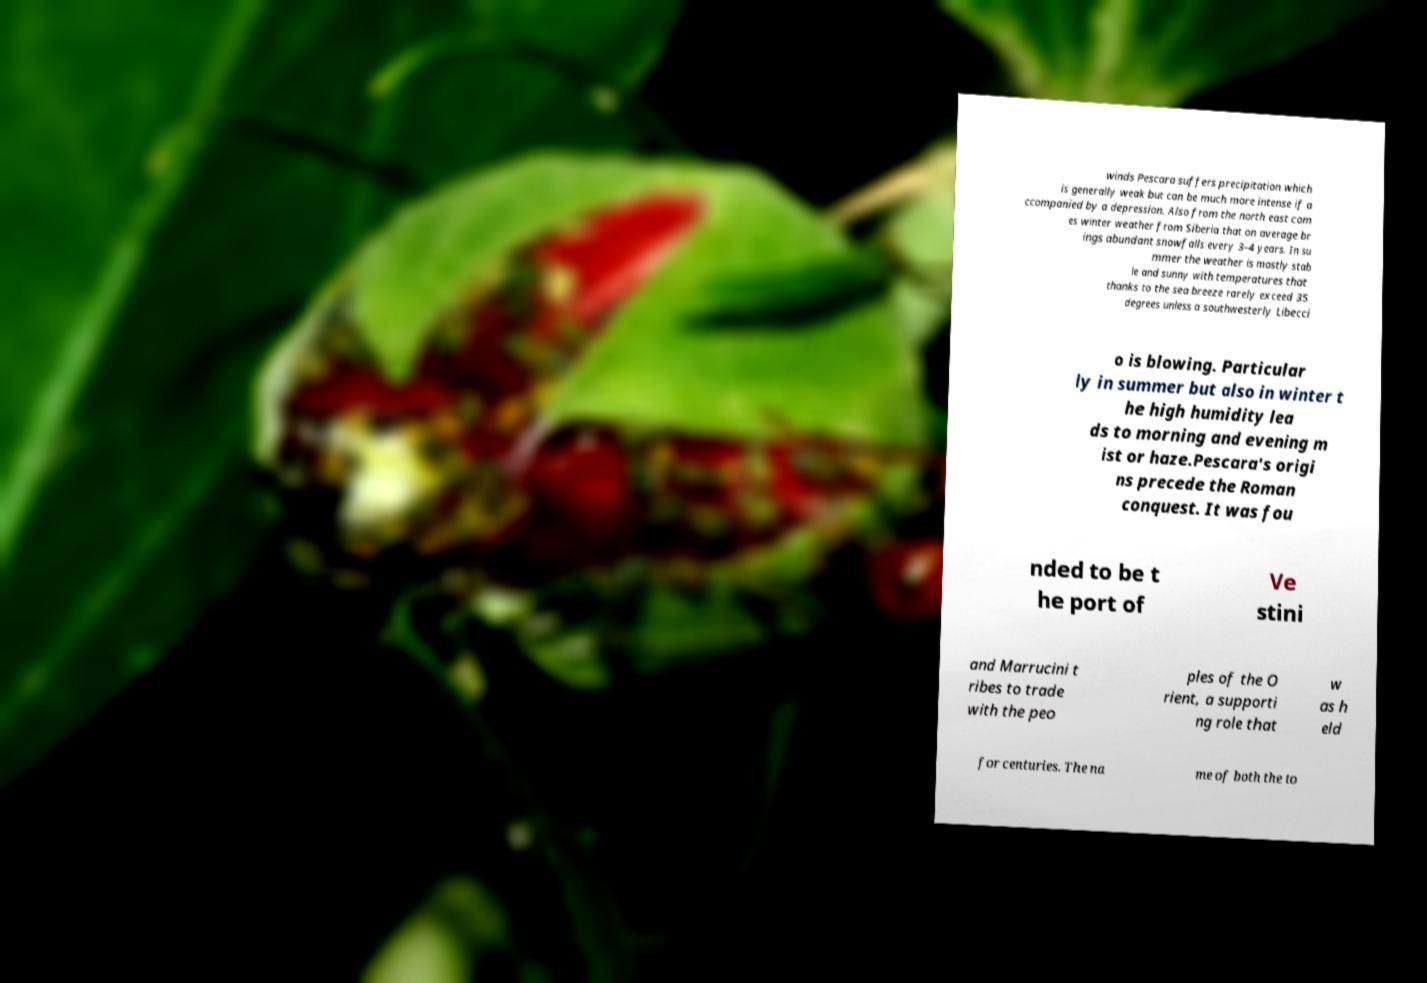Can you read and provide the text displayed in the image?This photo seems to have some interesting text. Can you extract and type it out for me? winds Pescara suffers precipitation which is generally weak but can be much more intense if a ccompanied by a depression. Also from the north east com es winter weather from Siberia that on average br ings abundant snowfalls every 3–4 years. In su mmer the weather is mostly stab le and sunny with temperatures that thanks to the sea breeze rarely exceed 35 degrees unless a southwesterly Libecci o is blowing. Particular ly in summer but also in winter t he high humidity lea ds to morning and evening m ist or haze.Pescara's origi ns precede the Roman conquest. It was fou nded to be t he port of Ve stini and Marrucini t ribes to trade with the peo ples of the O rient, a supporti ng role that w as h eld for centuries. The na me of both the to 